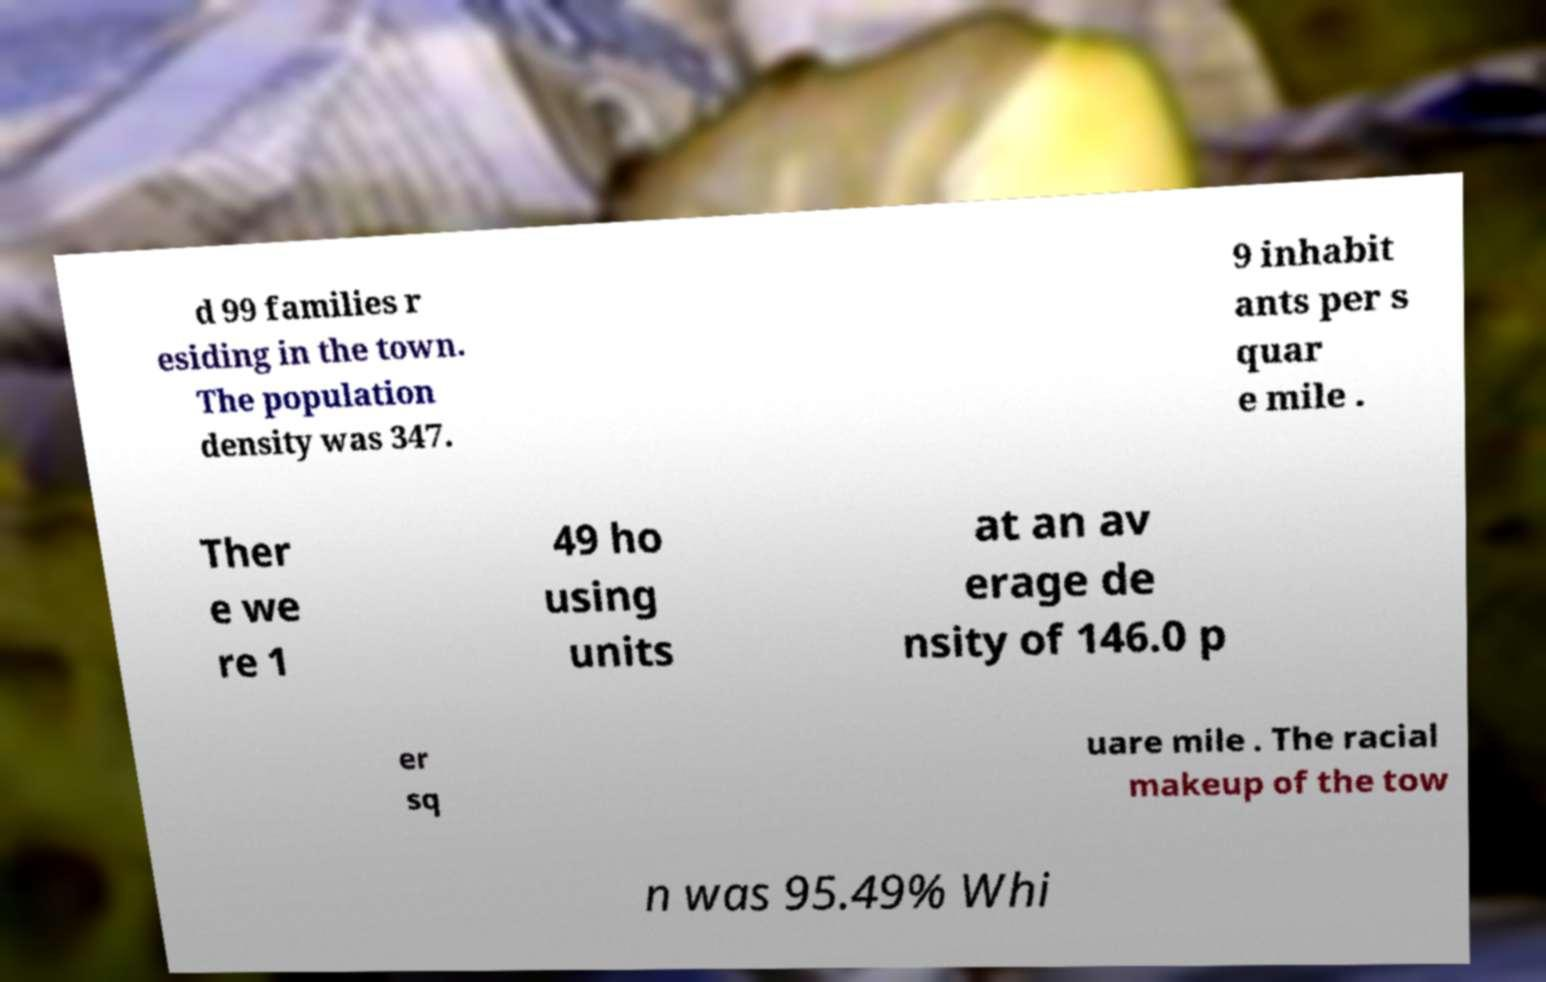What messages or text are displayed in this image? I need them in a readable, typed format. d 99 families r esiding in the town. The population density was 347. 9 inhabit ants per s quar e mile . Ther e we re 1 49 ho using units at an av erage de nsity of 146.0 p er sq uare mile . The racial makeup of the tow n was 95.49% Whi 